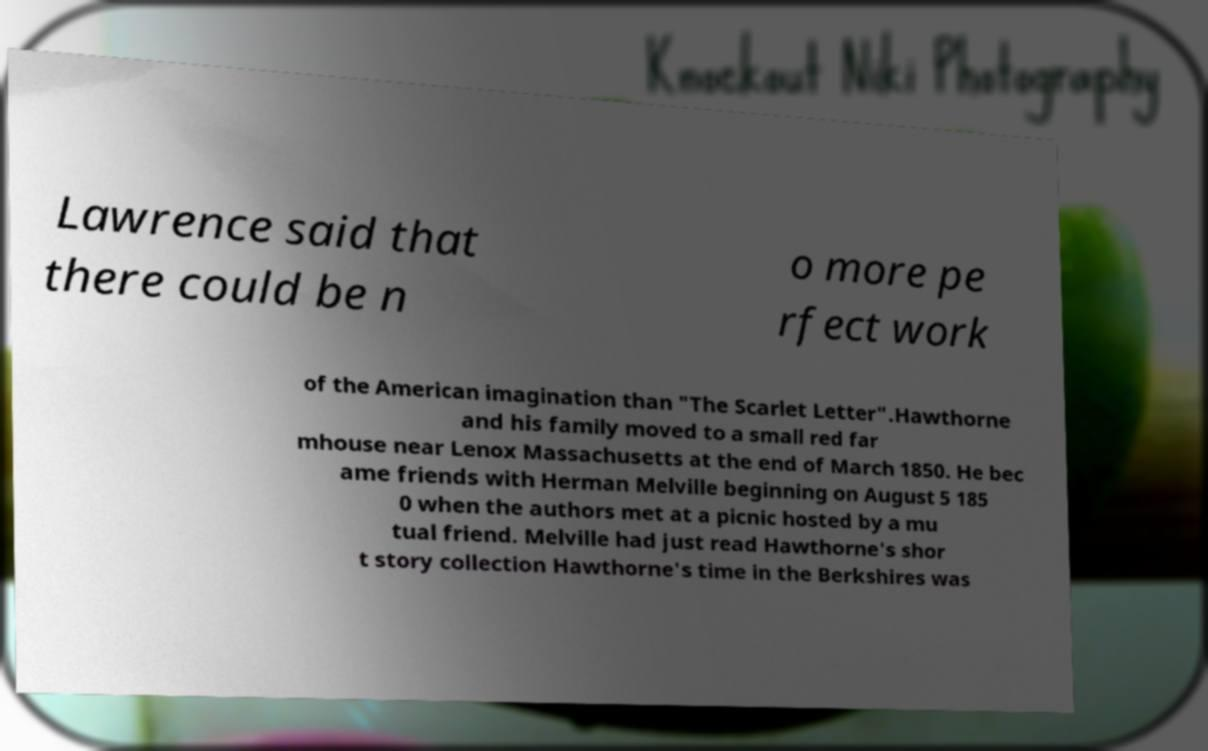Please read and relay the text visible in this image. What does it say? Lawrence said that there could be n o more pe rfect work of the American imagination than "The Scarlet Letter".Hawthorne and his family moved to a small red far mhouse near Lenox Massachusetts at the end of March 1850. He bec ame friends with Herman Melville beginning on August 5 185 0 when the authors met at a picnic hosted by a mu tual friend. Melville had just read Hawthorne's shor t story collection Hawthorne's time in the Berkshires was 